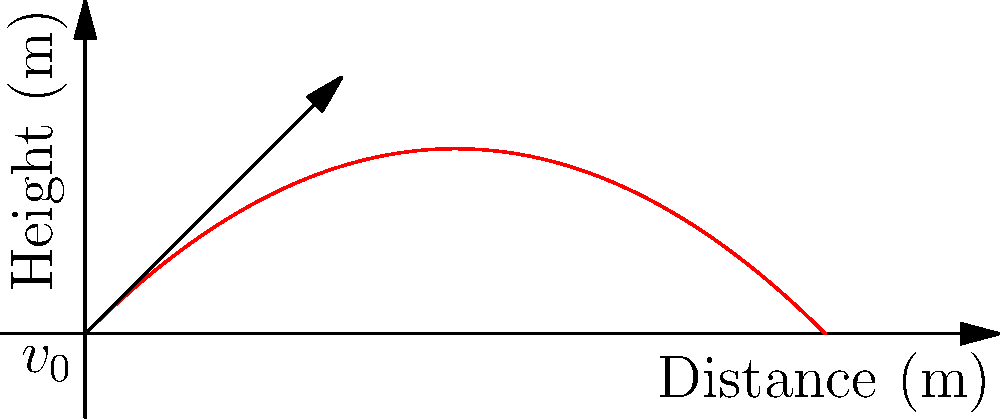A female javelin thrower launches a javelin with an initial velocity of 20 m/s at an angle of 45° above the horizontal. Assuming air resistance is negligible, what is the maximum height reached by the javelin? To find the maximum height reached by the javelin, we can follow these steps:

1. Identify the relevant equations:
   - Vertical motion: $y = v_0 \sin(\theta) t - \frac{1}{2}gt^2$
   - Initial vertical velocity: $v_y = v_0 \sin(\theta)$

2. The maximum height occurs when the vertical velocity becomes zero:
   $v_y = v_0 \sin(\theta) - gt = 0$

3. Solve for the time to reach maximum height:
   $t_{max} = \frac{v_0 \sin(\theta)}{g}$

4. Substitute the given values:
   $v_0 = 20$ m/s
   $\theta = 45° = \frac{\pi}{4}$ radians
   $g = 9.8$ m/s²

   $t_{max} = \frac{20 \sin(45°)}{9.8} = \frac{20 \cdot \frac{\sqrt{2}}{2}}{9.8} \approx 1.44$ s

5. Calculate the maximum height by substituting $t_{max}$ into the vertical motion equation:

   $h_{max} = v_0 \sin(\theta) t_{max} - \frac{1}{2}g(t_{max})^2$
   
   $h_{max} = 20 \sin(45°) \cdot 1.44 - \frac{1}{2} \cdot 9.8 \cdot (1.44)^2$
   
   $h_{max} = 20 \cdot \frac{\sqrt{2}}{2} \cdot 1.44 - 4.9 \cdot 2.07$
   
   $h_{max} \approx 10.2$ m

Therefore, the maximum height reached by the javelin is approximately 10.2 meters.
Answer: 10.2 m 